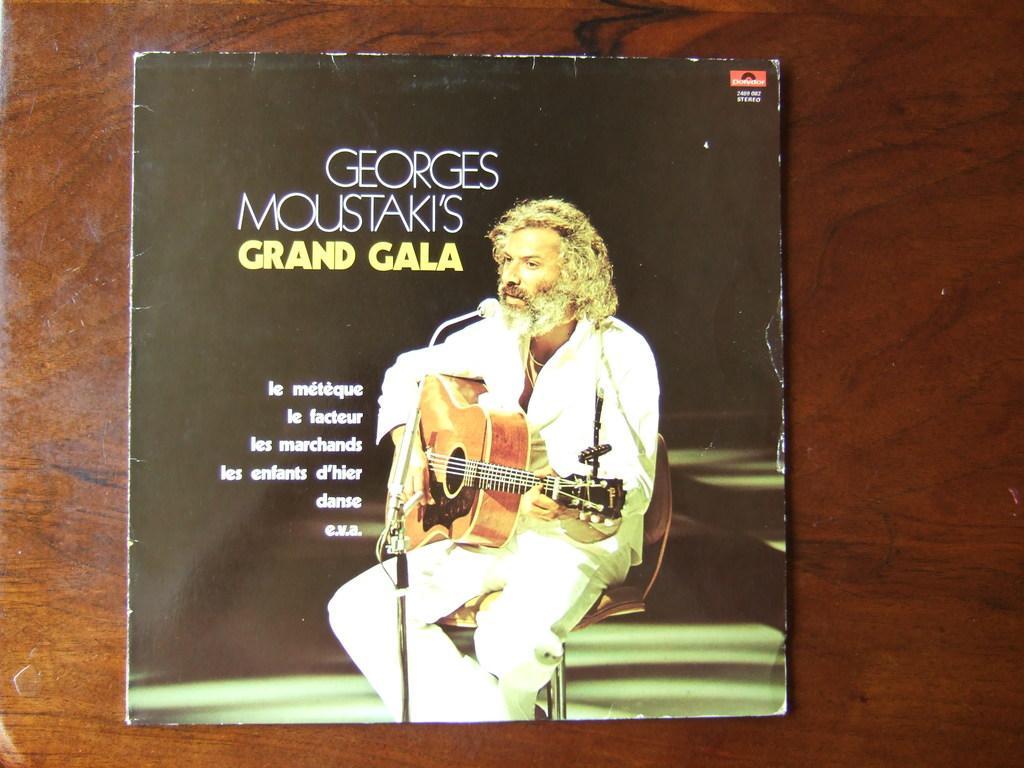How would you summarize this image in a sentence or two? In this picture, I can see a book which is kept and on top of the book, We can see a image a person sitting in chair and playing musical instrument. 